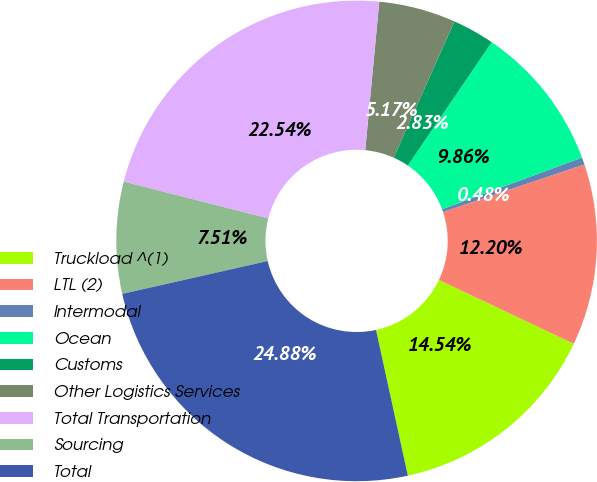Convert chart. <chart><loc_0><loc_0><loc_500><loc_500><pie_chart><fcel>Truckload ^(1)<fcel>LTL (2)<fcel>Intermodal<fcel>Ocean<fcel>Customs<fcel>Other Logistics Services<fcel>Total Transportation<fcel>Sourcing<fcel>Total<nl><fcel>14.54%<fcel>12.2%<fcel>0.48%<fcel>9.86%<fcel>2.83%<fcel>5.17%<fcel>22.54%<fcel>7.51%<fcel>24.88%<nl></chart> 